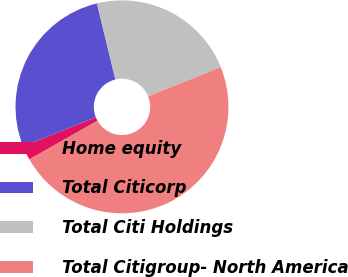Convert chart. <chart><loc_0><loc_0><loc_500><loc_500><pie_chart><fcel>Home equity<fcel>Total Citicorp<fcel>Total Citi Holdings<fcel>Total Citigroup- North America<nl><fcel>2.16%<fcel>27.27%<fcel>22.7%<fcel>47.86%<nl></chart> 